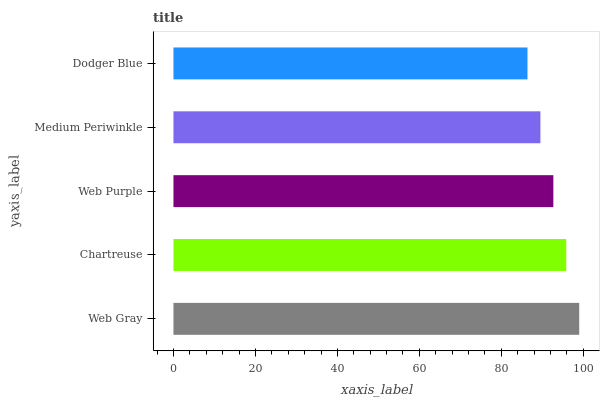Is Dodger Blue the minimum?
Answer yes or no. Yes. Is Web Gray the maximum?
Answer yes or no. Yes. Is Chartreuse the minimum?
Answer yes or no. No. Is Chartreuse the maximum?
Answer yes or no. No. Is Web Gray greater than Chartreuse?
Answer yes or no. Yes. Is Chartreuse less than Web Gray?
Answer yes or no. Yes. Is Chartreuse greater than Web Gray?
Answer yes or no. No. Is Web Gray less than Chartreuse?
Answer yes or no. No. Is Web Purple the high median?
Answer yes or no. Yes. Is Web Purple the low median?
Answer yes or no. Yes. Is Chartreuse the high median?
Answer yes or no. No. Is Chartreuse the low median?
Answer yes or no. No. 